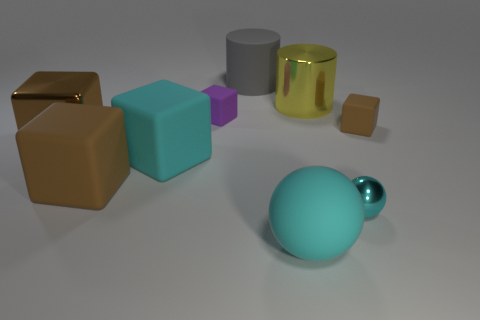Subtract all tiny brown cubes. How many cubes are left? 4 Subtract all blocks. How many objects are left? 4 Subtract all cyan blocks. How many blocks are left? 4 Add 1 tiny cyan metal cylinders. How many objects exist? 10 Subtract all large cylinders. Subtract all yellow cylinders. How many objects are left? 6 Add 3 small balls. How many small balls are left? 4 Add 3 red cubes. How many red cubes exist? 3 Subtract 0 gray blocks. How many objects are left? 9 Subtract 5 cubes. How many cubes are left? 0 Subtract all red cylinders. Subtract all red blocks. How many cylinders are left? 2 